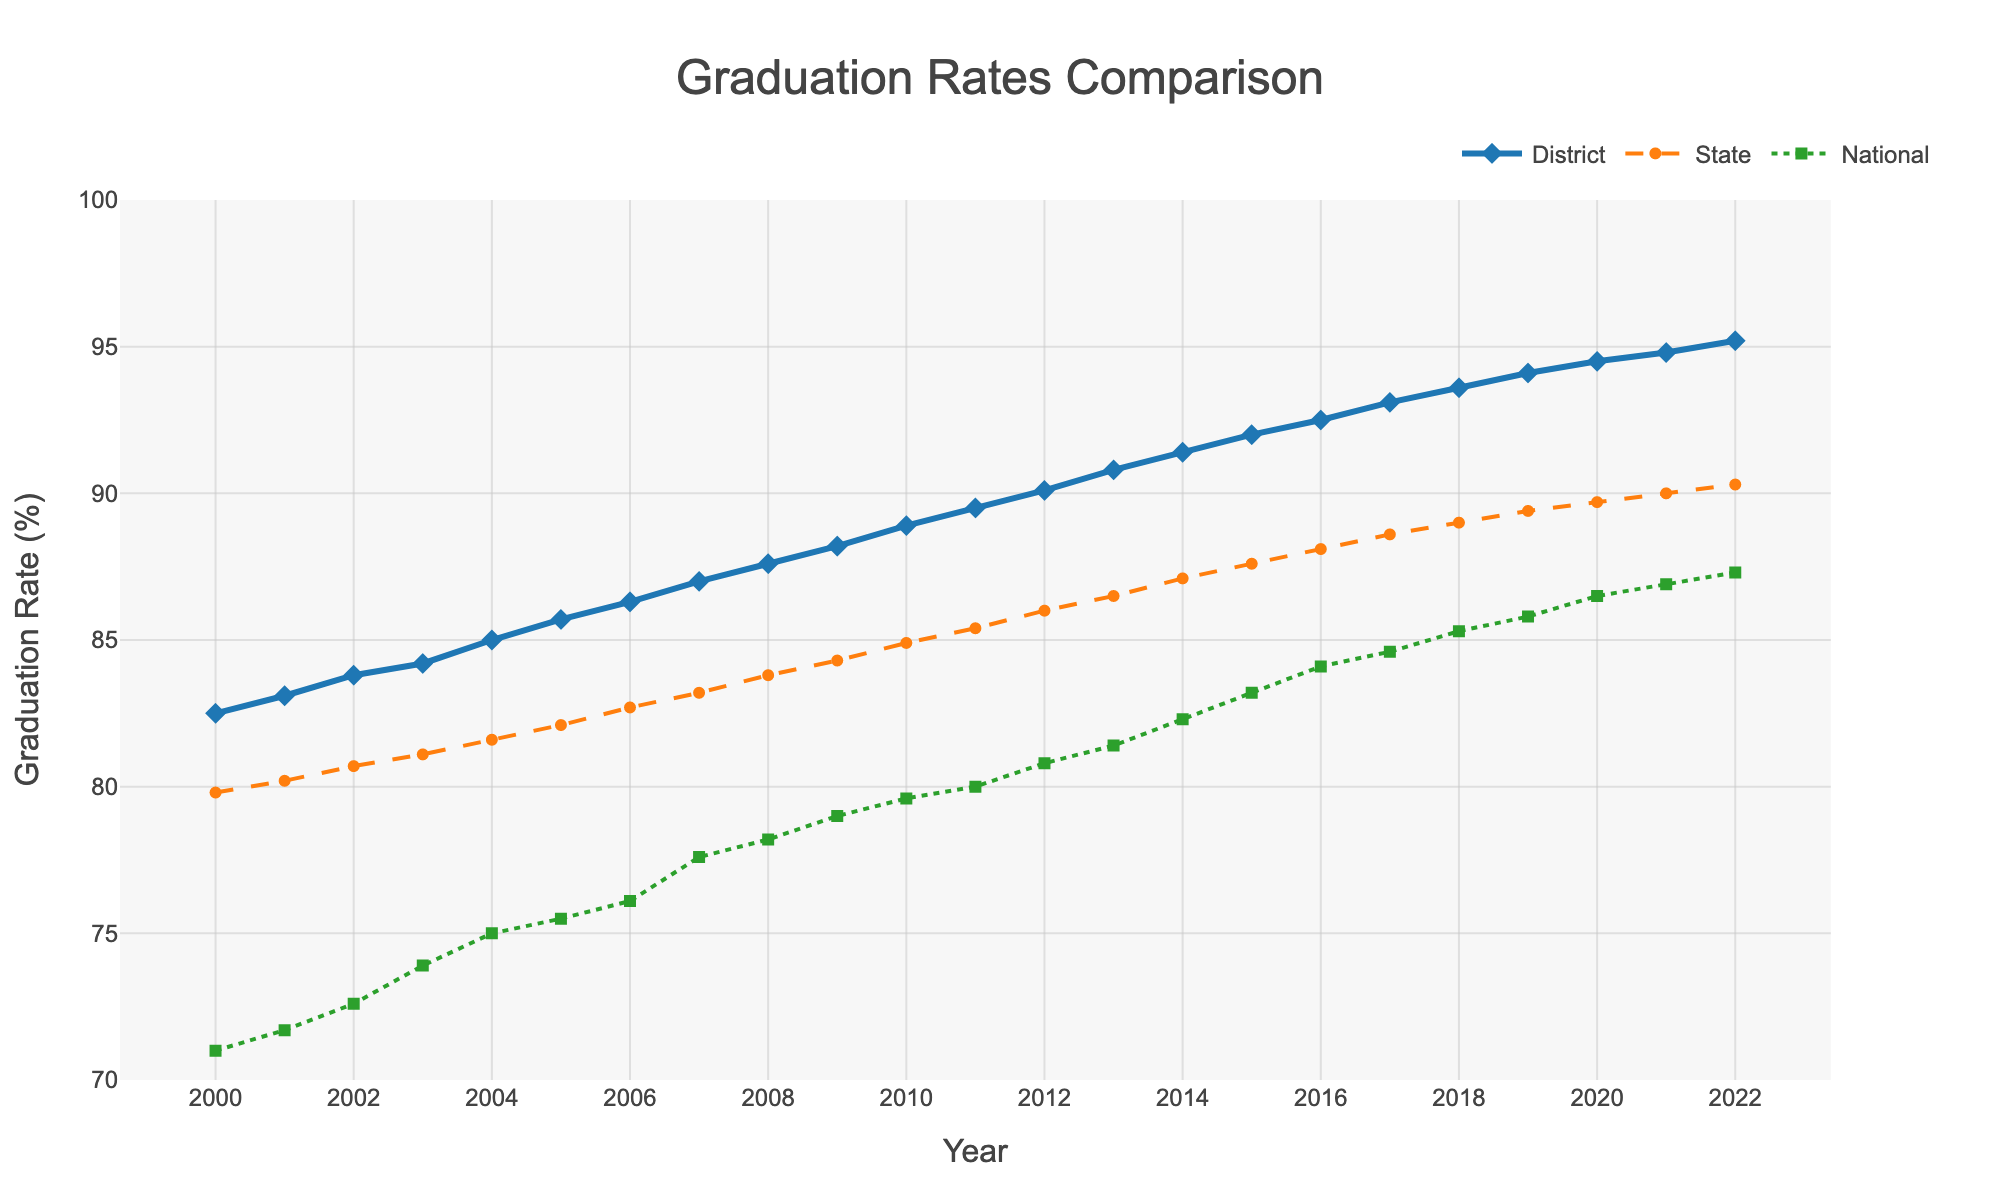What year did the district first surpass a 90% graduation rate? In the figure, you need to identify the point where the district's graduation rate line crosses the 90% mark. This happens for the first time in 2012.
Answer: 2012 Which year had the largest gap between the district and the national average graduation rates? To determine this, you need to compare the differences between the District Graduation Rate and National Average for each year and identify the largest gap. The year with the largest gap is 2022.
Answer: 2022 How does the graduation rate trend of our district compare to the state average between 2000 and 2022? Visually, both the District and State lines are upward-sloping over the years. The district's line consistently stays above the state average and maintains a positive trend, indicating overall improvement for both but with the district always leading.
Answer: The district's trend is consistently higher and both show improvement What is the percentage increase in the district graduation rate from 2000 to 2022? Calculate the percentage increase using the formula: ((value in 2022 - value in 2000) / value in 2000) * 100. For the district: ((95.2 - 82.5) / 82.5) * 100 = 15.39%.
Answer: 15.39% In which year was the smallest gap between the District and State graduation rates observed? You need to find the year where the difference between the district and state graduation rates is the smallest. By examining the plot, 2021 had the smallest gap.
Answer: 2021 What is the average graduation rate for the district from 2010 to 2022? Calculate the average by summing the rates from 2010 to 2022, then dividing by the number of years. (88.9 + 89.5 + 90.1 + 90.8 + 91.4 + 92.0 + 92.5 + 93.1 + 93.6 + 94.1 + 94.5 + 94.8 + 95.2) / 13 = 91.97.
Answer: 91.97% How much higher was the district's graduation rate compared to the national average in 2020? Subtract the national average from the district rate for 2020. 94.5 - 86.5 = 8.0.
Answer: 8.0 Which entity had the steadiest increase in graduation rates over the years, the district, state, or the nation? By analyzing the slopes of the lines in the plot, the district has the steadiest and most consistent increase over the years.
Answer: The district How did the national average graduation rate compare to the state average in the year 2004? Identify the rates for both state and national averages in 2004 and compare them. The national average was 75.0%, and the state average was 81.6%.
Answer: The state average was higher than the national average What visual elements are used to distinguish between the district, state, and national average lines? By examining the plot, the district line is blue with diamond markers, the state line is orange with dashed segments and circle markers, and the national line is green with dotted segments and square markers.
Answer: Color, line style, and marker shapes 